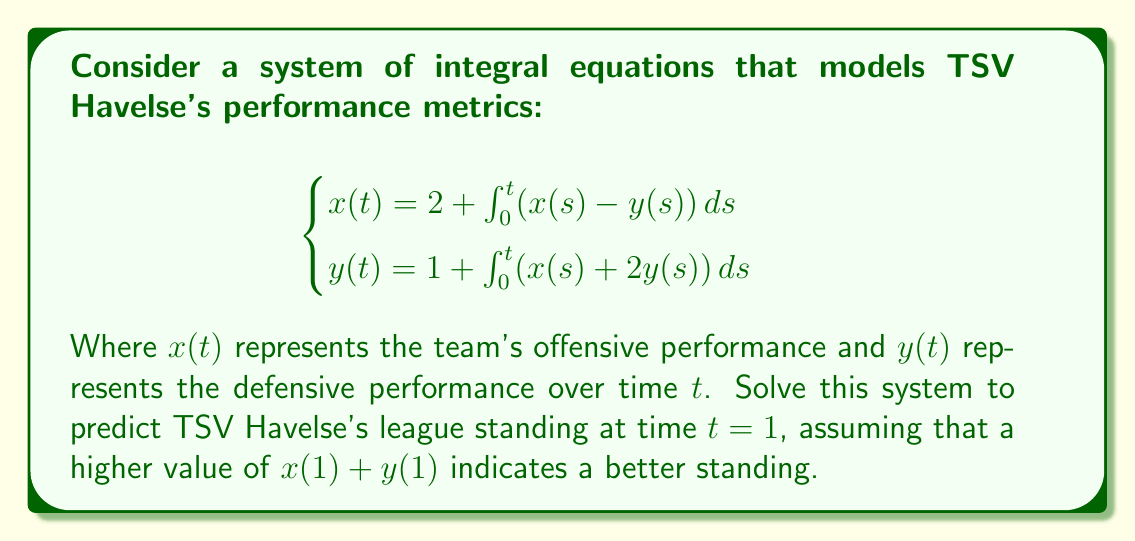Can you answer this question? Let's solve this step-by-step:

1) First, we differentiate both equations with respect to $t$:
   $$\begin{cases}
   x'(t) = x(t) - y(t) \\
   y'(t) = x(t) + 2y(t)
   \end{cases}$$

2) Now we have a system of ordinary differential equations. Let's solve it using the matrix method:
   $$\begin{pmatrix} x'(t) \\ y'(t) \end{pmatrix} = \begin{pmatrix} 1 & -1 \\ 1 & 2 \end{pmatrix} \begin{pmatrix} x(t) \\ y(t) \end{pmatrix}$$

3) The characteristic equation is:
   $$\det(\lambda I - A) = \begin{vmatrix} \lambda - 1 & 1 \\ -1 & \lambda - 2 \end{vmatrix} = \lambda^2 - 3\lambda + 1 = 0$$

4) Solving this, we get eigenvalues $\lambda_1 = \frac{3+\sqrt{5}}{2}$ and $\lambda_2 = \frac{3-\sqrt{5}}{2}$

5) The corresponding eigenvectors are:
   $$v_1 = \begin{pmatrix} \frac{\sqrt{5}+1}{2} \\ 1 \end{pmatrix}, v_2 = \begin{pmatrix} \frac{-\sqrt{5}+1}{2} \\ 1 \end{pmatrix}$$

6) The general solution is:
   $$\begin{pmatrix} x(t) \\ y(t) \end{pmatrix} = c_1e^{\lambda_1t}v_1 + c_2e^{\lambda_2t}v_2$$

7) Using the initial conditions $x(0) = 2$ and $y(0) = 1$, we can find $c_1$ and $c_2$:
   $$\begin{cases}
   2 = c_1\frac{\sqrt{5}+1}{2} + c_2\frac{-\sqrt{5}+1}{2} \\
   1 = c_1 + c_2
   \end{cases}$$

   Solving this, we get $c_1 = \frac{\sqrt{5}+1}{2\sqrt{5}}$ and $c_2 = \frac{-\sqrt{5}+1}{2\sqrt{5}}$

8) Now we can find $x(1)$ and $y(1)$:
   $$\begin{align}
   x(1) &= c_1e^{\lambda_1}\frac{\sqrt{5}+1}{2} + c_2e^{\lambda_2}\frac{-\sqrt{5}+1}{2} \\
   y(1) &= c_1e^{\lambda_1} + c_2e^{\lambda_2}
   \end{align}$$

9) Calculating these values:
   $$x(1) \approx 3.30, y(1) \approx 2.37$$

10) The team's standing indicator is $x(1) + y(1) \approx 5.67$
Answer: $x(1) + y(1) \approx 5.67$ 